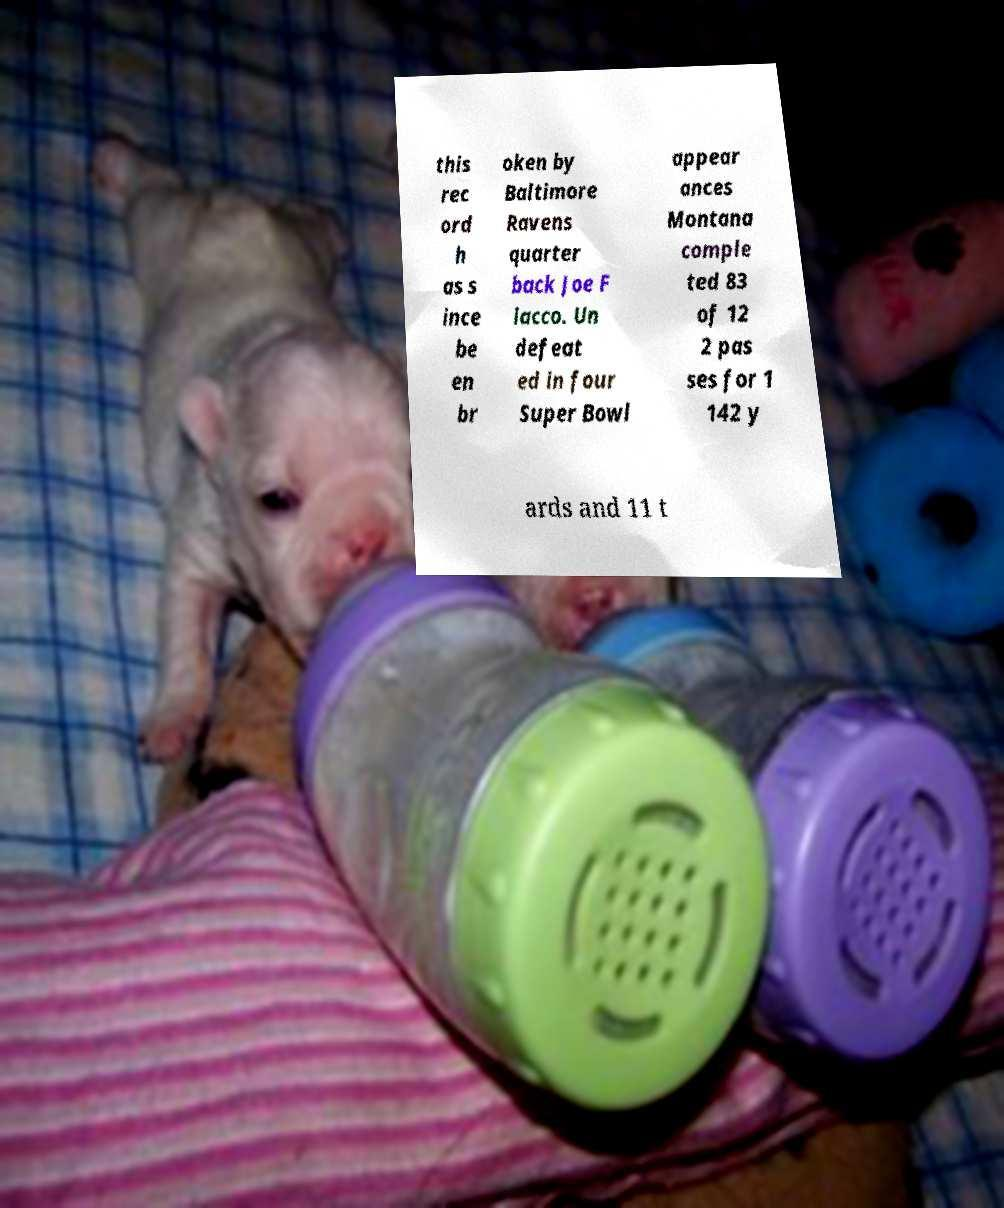There's text embedded in this image that I need extracted. Can you transcribe it verbatim? this rec ord h as s ince be en br oken by Baltimore Ravens quarter back Joe F lacco. Un defeat ed in four Super Bowl appear ances Montana comple ted 83 of 12 2 pas ses for 1 142 y ards and 11 t 